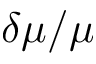Convert formula to latex. <formula><loc_0><loc_0><loc_500><loc_500>\delta \mu / \mu</formula> 